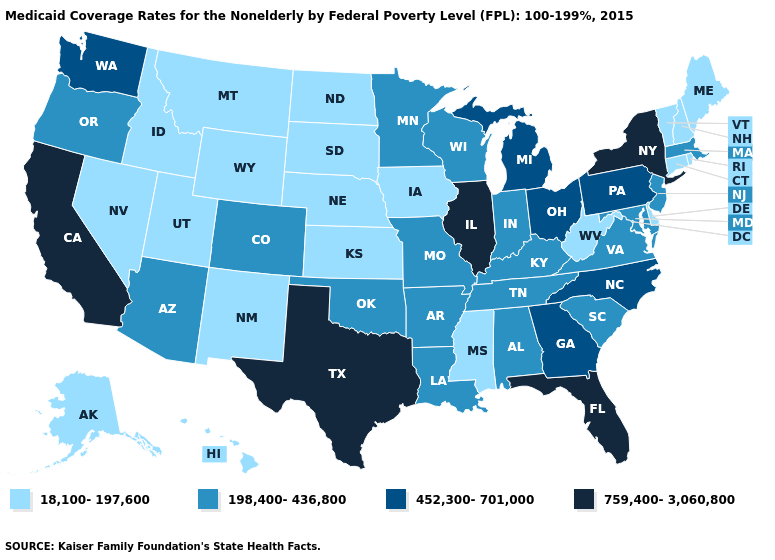Name the states that have a value in the range 198,400-436,800?
Keep it brief. Alabama, Arizona, Arkansas, Colorado, Indiana, Kentucky, Louisiana, Maryland, Massachusetts, Minnesota, Missouri, New Jersey, Oklahoma, Oregon, South Carolina, Tennessee, Virginia, Wisconsin. What is the highest value in the South ?
Quick response, please. 759,400-3,060,800. What is the value of Utah?
Give a very brief answer. 18,100-197,600. Name the states that have a value in the range 452,300-701,000?
Write a very short answer. Georgia, Michigan, North Carolina, Ohio, Pennsylvania, Washington. Which states hav the highest value in the MidWest?
Concise answer only. Illinois. What is the value of New York?
Answer briefly. 759,400-3,060,800. What is the highest value in the USA?
Write a very short answer. 759,400-3,060,800. Among the states that border Idaho , which have the lowest value?
Keep it brief. Montana, Nevada, Utah, Wyoming. What is the value of Alabama?
Short answer required. 198,400-436,800. Name the states that have a value in the range 198,400-436,800?
Answer briefly. Alabama, Arizona, Arkansas, Colorado, Indiana, Kentucky, Louisiana, Maryland, Massachusetts, Minnesota, Missouri, New Jersey, Oklahoma, Oregon, South Carolina, Tennessee, Virginia, Wisconsin. Does Illinois have the highest value in the USA?
Concise answer only. Yes. Does the first symbol in the legend represent the smallest category?
Quick response, please. Yes. What is the lowest value in the USA?
Give a very brief answer. 18,100-197,600. What is the lowest value in the USA?
Give a very brief answer. 18,100-197,600. Among the states that border North Carolina , does Georgia have the highest value?
Short answer required. Yes. 